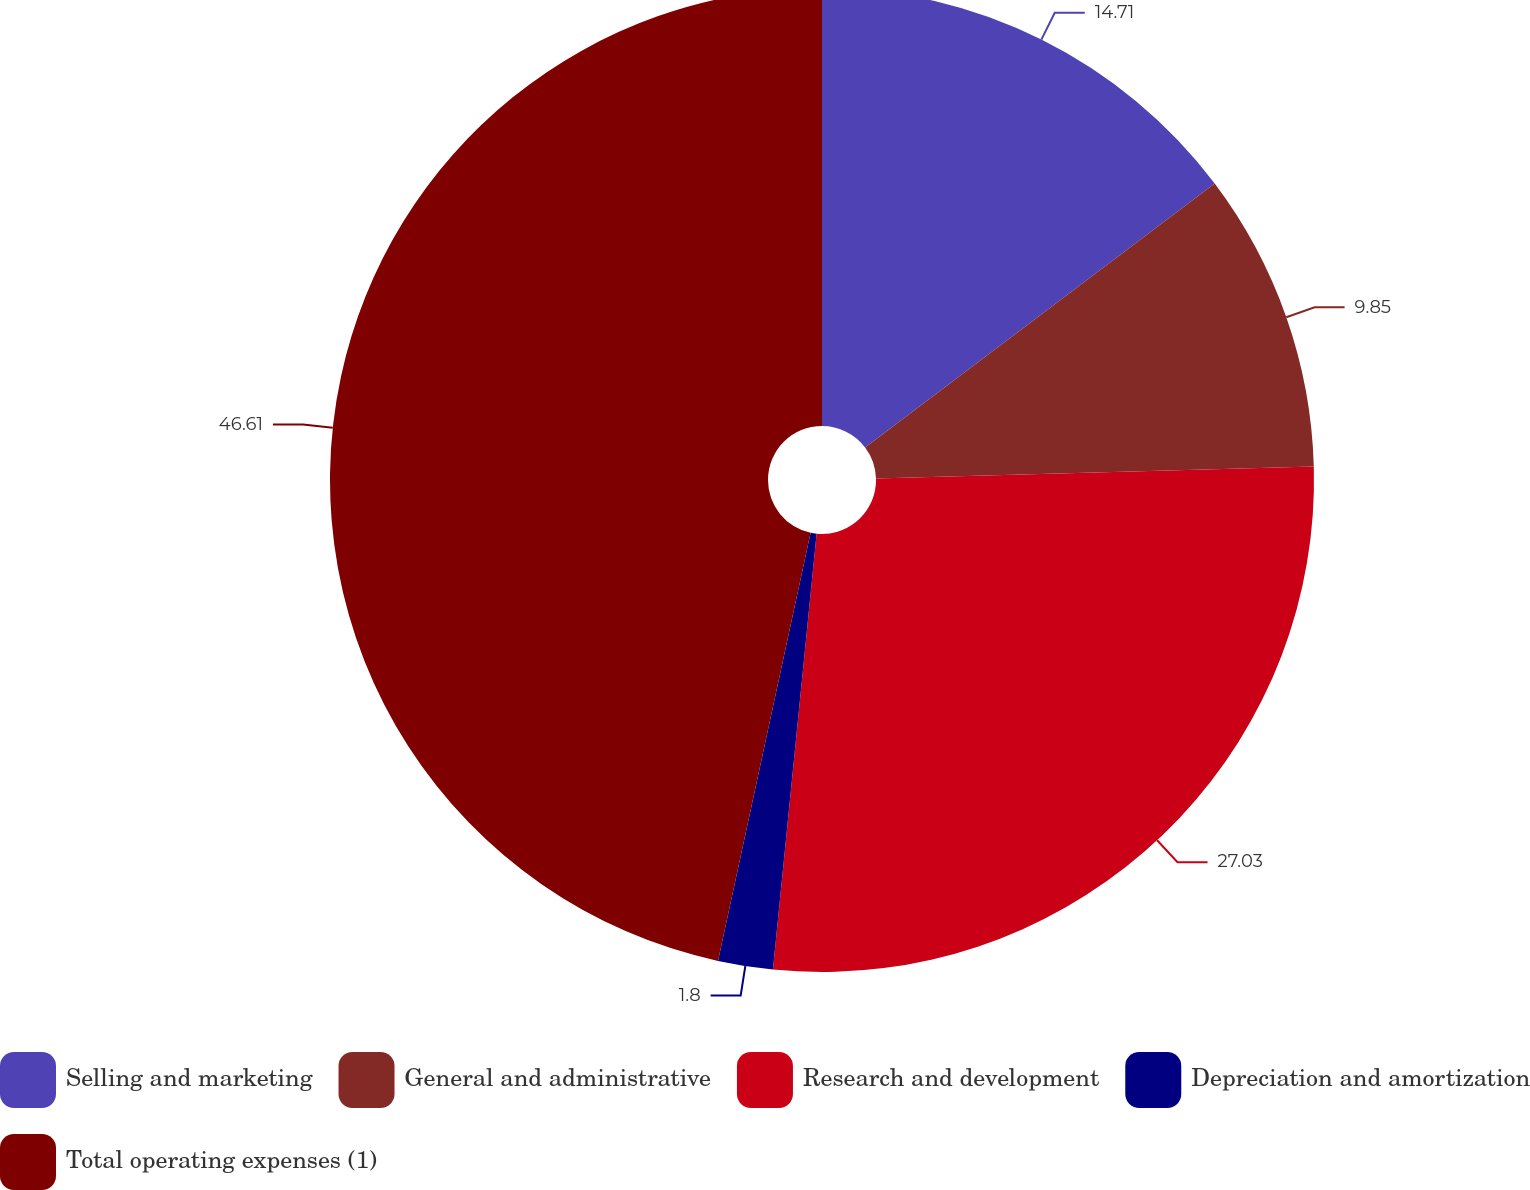Convert chart to OTSL. <chart><loc_0><loc_0><loc_500><loc_500><pie_chart><fcel>Selling and marketing<fcel>General and administrative<fcel>Research and development<fcel>Depreciation and amortization<fcel>Total operating expenses (1)<nl><fcel>14.71%<fcel>9.85%<fcel>27.03%<fcel>1.8%<fcel>46.61%<nl></chart> 